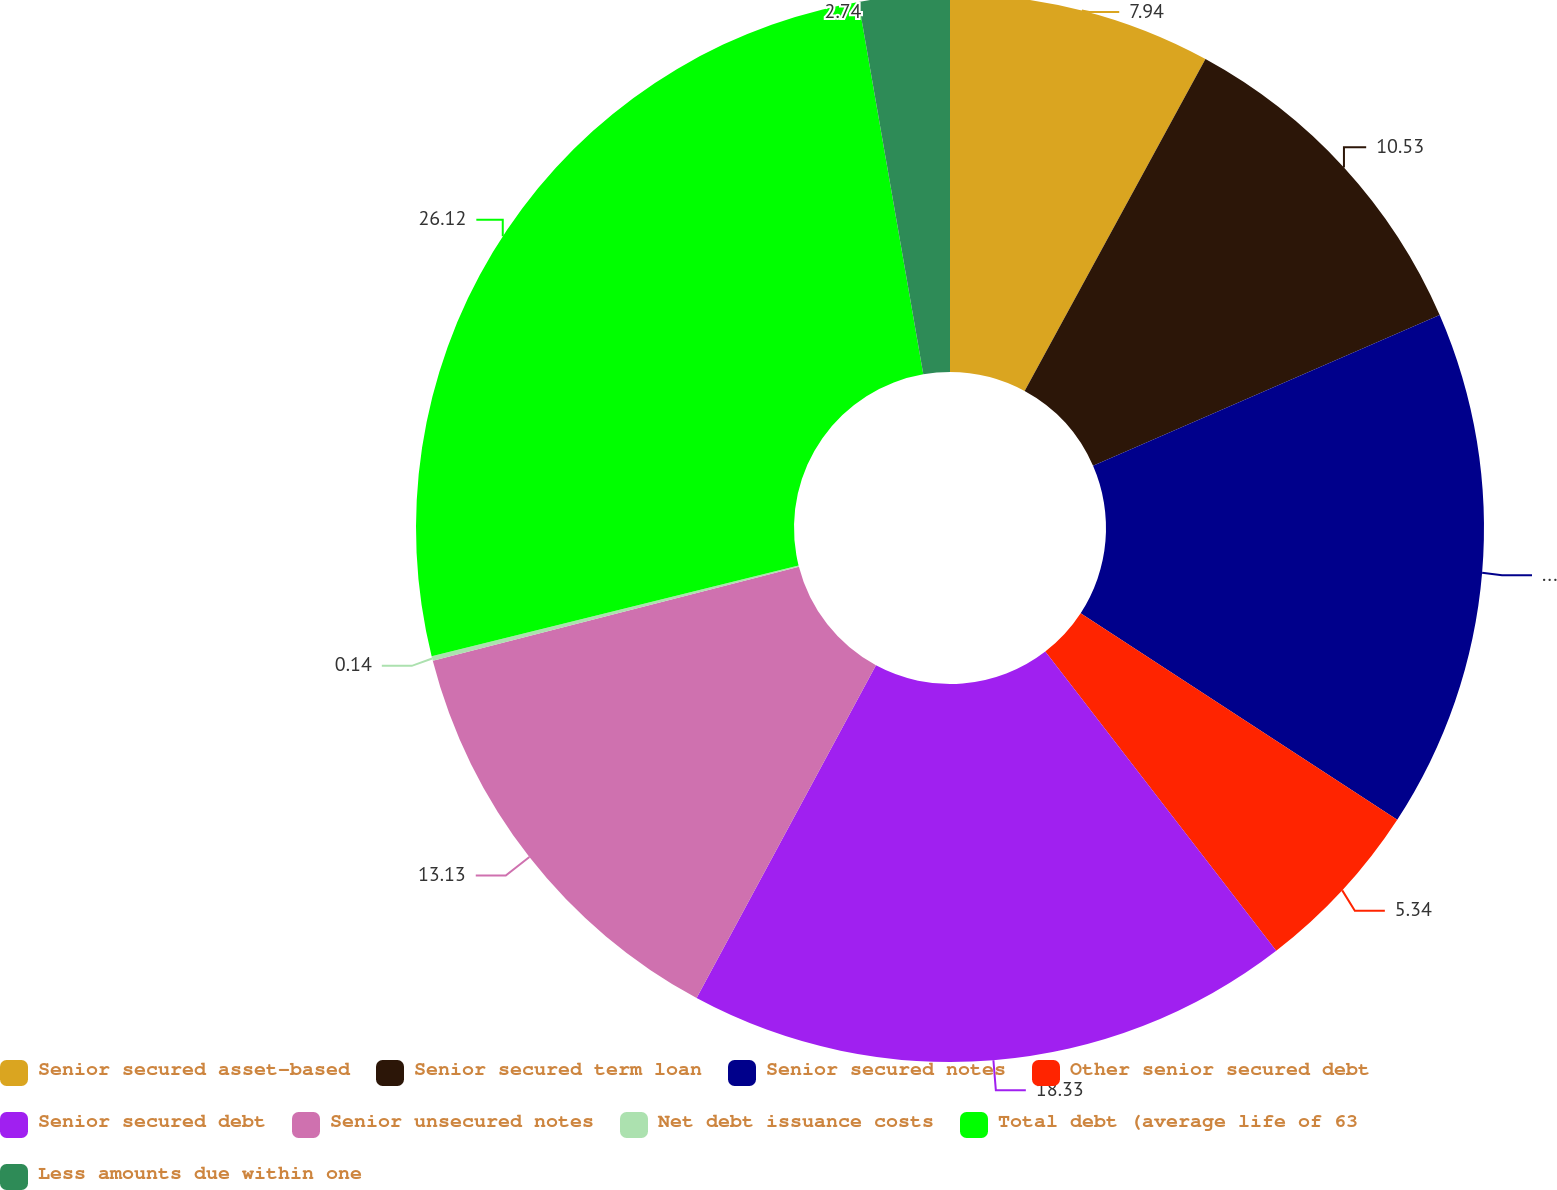Convert chart to OTSL. <chart><loc_0><loc_0><loc_500><loc_500><pie_chart><fcel>Senior secured asset-based<fcel>Senior secured term loan<fcel>Senior secured notes<fcel>Other senior secured debt<fcel>Senior secured debt<fcel>Senior unsecured notes<fcel>Net debt issuance costs<fcel>Total debt (average life of 63<fcel>Less amounts due within one<nl><fcel>7.94%<fcel>10.53%<fcel>15.73%<fcel>5.34%<fcel>18.33%<fcel>13.13%<fcel>0.14%<fcel>26.12%<fcel>2.74%<nl></chart> 